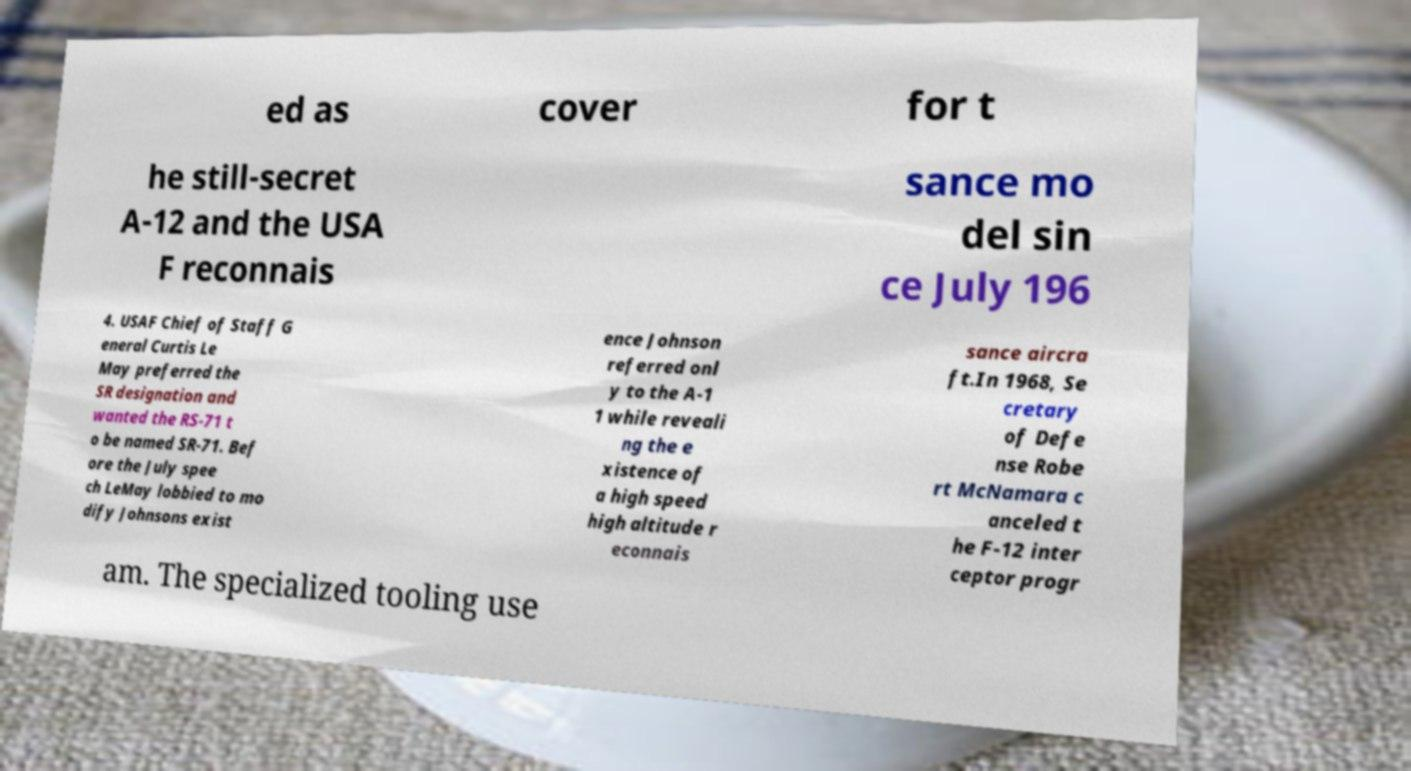Please identify and transcribe the text found in this image. ed as cover for t he still-secret A-12 and the USA F reconnais sance mo del sin ce July 196 4. USAF Chief of Staff G eneral Curtis Le May preferred the SR designation and wanted the RS-71 t o be named SR-71. Bef ore the July spee ch LeMay lobbied to mo dify Johnsons exist ence Johnson referred onl y to the A-1 1 while reveali ng the e xistence of a high speed high altitude r econnais sance aircra ft.In 1968, Se cretary of Defe nse Robe rt McNamara c anceled t he F-12 inter ceptor progr am. The specialized tooling use 